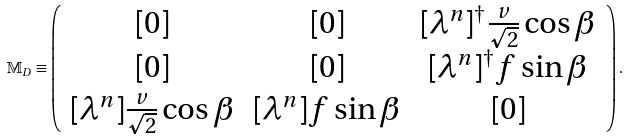<formula> <loc_0><loc_0><loc_500><loc_500>\mathbb { M } _ { D } \equiv \left ( \begin{array} { c c c } [ 0 ] & [ 0 ] & [ \lambda ^ { n } ] ^ { \dagger } \frac { v } { \sqrt { 2 } } \cos \beta \\ { [ 0 ] } & [ 0 ] & [ \lambda ^ { n } ] ^ { \dagger } f \sin \beta \\ { [ \lambda ^ { n } ] } \frac { v } { \sqrt { 2 } } \cos \beta & [ \lambda ^ { n } ] f \sin \beta & [ 0 ] \end{array} \right ) .</formula> 